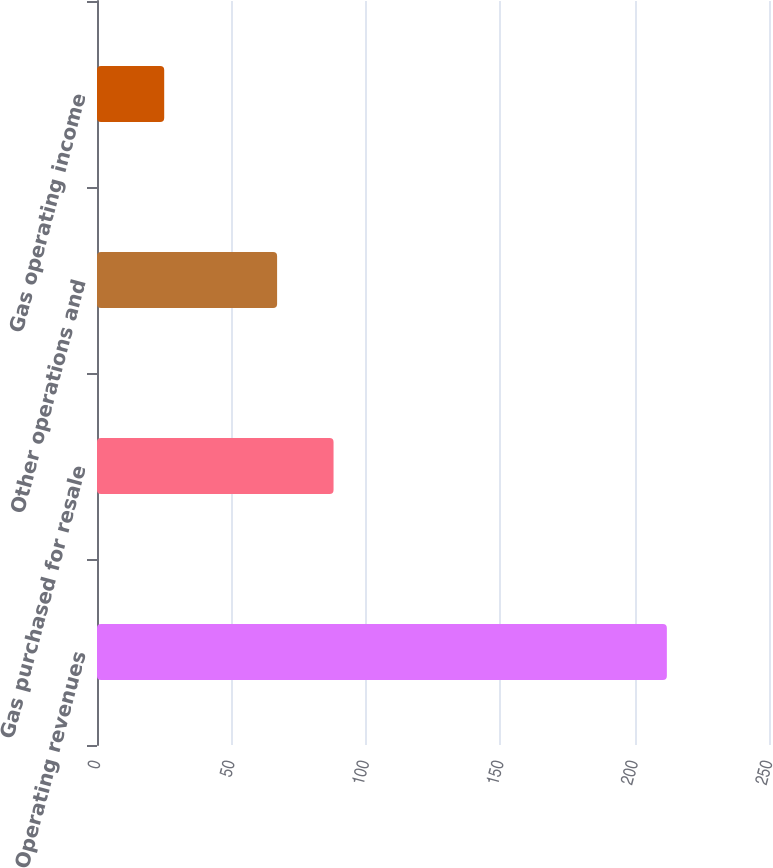Convert chart. <chart><loc_0><loc_0><loc_500><loc_500><bar_chart><fcel>Operating revenues<fcel>Gas purchased for resale<fcel>Other operations and<fcel>Gas operating income<nl><fcel>212<fcel>88<fcel>67<fcel>25<nl></chart> 